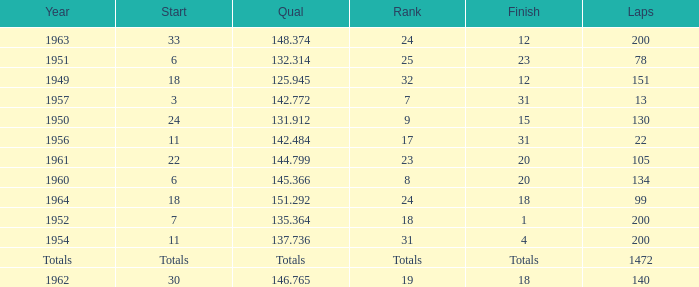Could you parse the entire table as a dict? {'header': ['Year', 'Start', 'Qual', 'Rank', 'Finish', 'Laps'], 'rows': [['1963', '33', '148.374', '24', '12', '200'], ['1951', '6', '132.314', '25', '23', '78'], ['1949', '18', '125.945', '32', '12', '151'], ['1957', '3', '142.772', '7', '31', '13'], ['1950', '24', '131.912', '9', '15', '130'], ['1956', '11', '142.484', '17', '31', '22'], ['1961', '22', '144.799', '23', '20', '105'], ['1960', '6', '145.366', '8', '20', '134'], ['1964', '18', '151.292', '24', '18', '99'], ['1952', '7', '135.364', '18', '1', '200'], ['1954', '11', '137.736', '31', '4', '200'], ['Totals', 'Totals', 'Totals', 'Totals', 'Totals', '1472'], ['1962', '30', '146.765', '19', '18', '140']]} Name the rank for 151 Laps 32.0. 